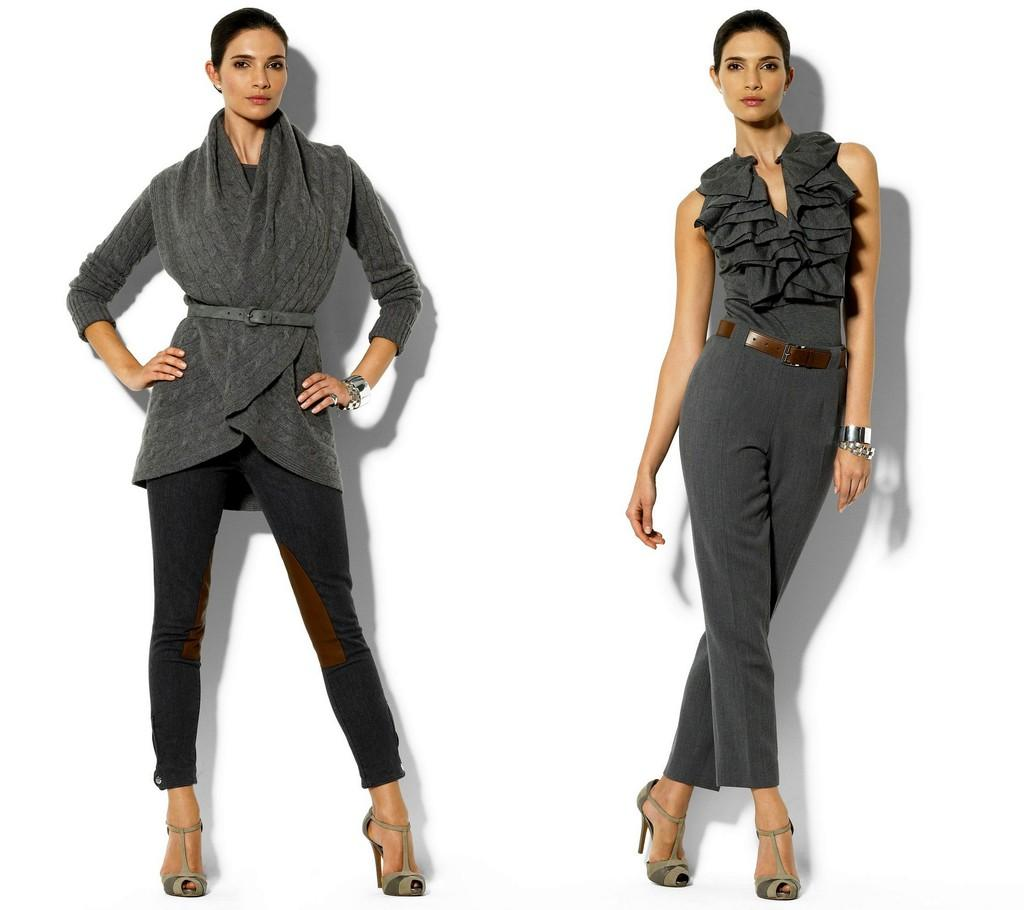What is the position of the woman wearing a dress in the image? The woman wearing a dress is on the right side of the image. What type of clothing is the woman on the right wearing? The woman on the right is wearing a dress and a belt. What is the position of the woman wearing a jacket in the image? The woman wearing a jacket is on the left side of the image. What type of clothing is the woman on the left wearing? The woman on the left is wearing a jacket and trousers. What type of cream can be seen on the beetle in the image? There is no beetle or cream present in the image. How many sticks are being held by the women in the image? There are no sticks visible in the image. 